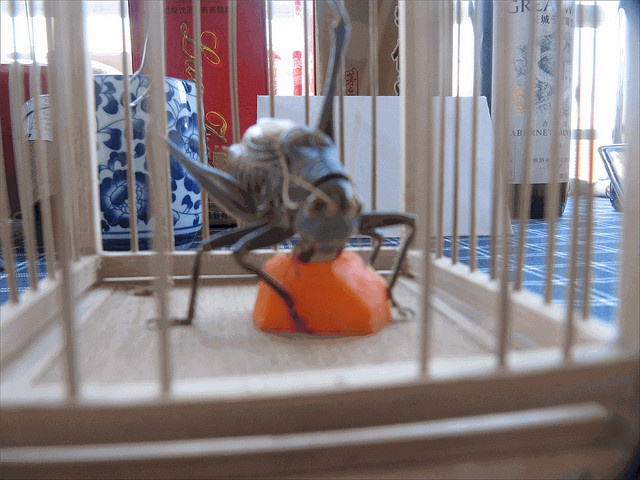Describe the objects in this image and their specific colors. I can see cup in darkgray, gray, and navy tones, bottle in darkgray and gray tones, orange in darkgray, brown, salmon, and lightpink tones, carrot in darkgray, brown, salmon, and lightpink tones, and chair in darkgray, lightgray, and lightblue tones in this image. 